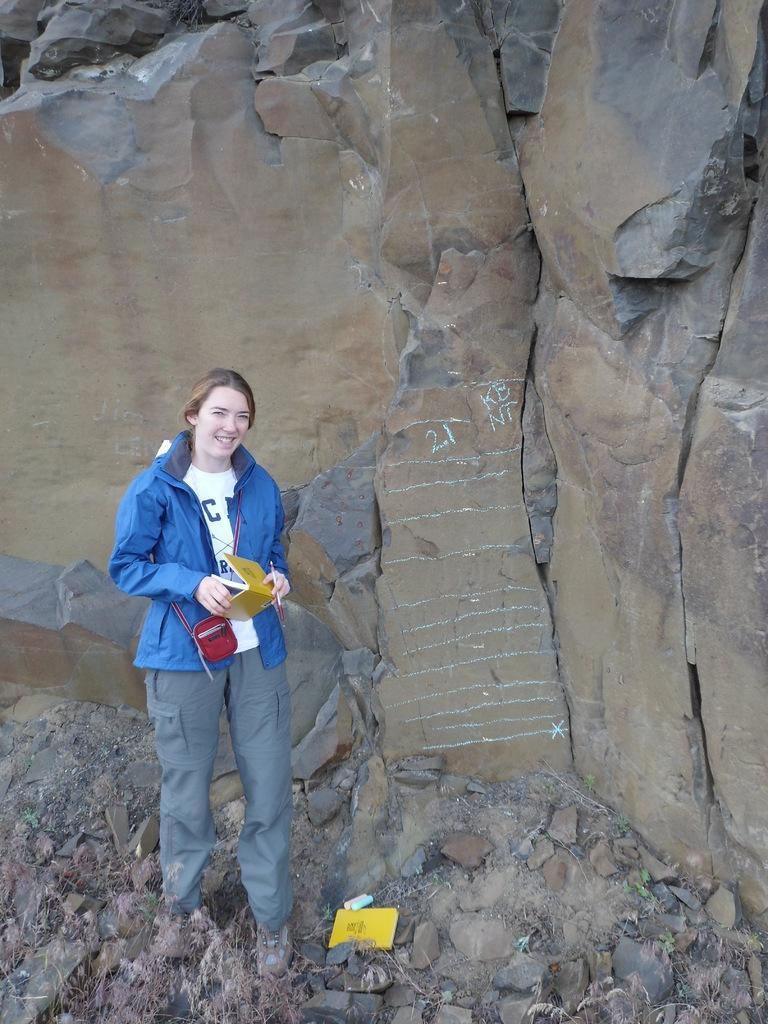In one or two sentences, can you explain what this image depicts? In the foreground there are stones and a woman. The woman is holding a book. In the background it is a rock. 